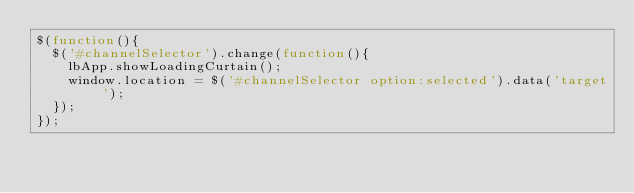Convert code to text. <code><loc_0><loc_0><loc_500><loc_500><_JavaScript_>$(function(){
  $('#channelSelector').change(function(){
    lbApp.showLoadingCurtain();
    window.location = $('#channelSelector option:selected').data('target');
  });
});
</code> 